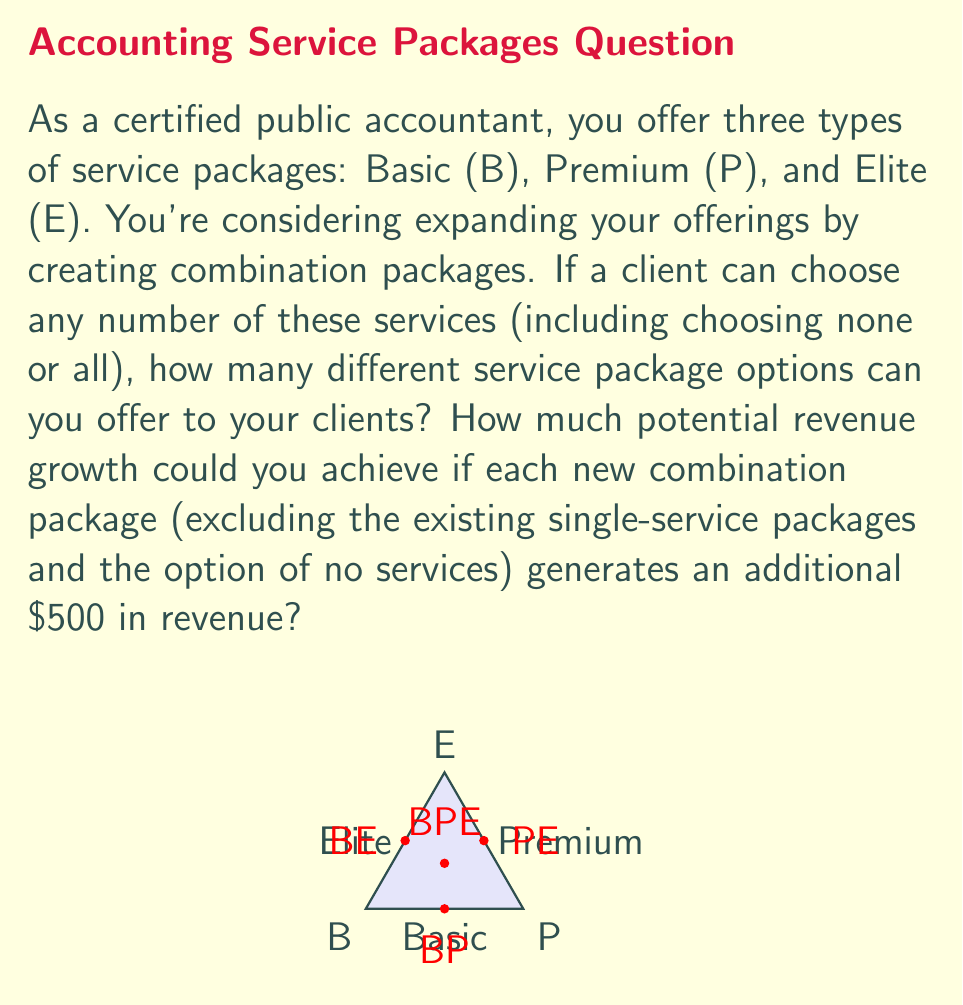Teach me how to tackle this problem. Let's approach this problem step-by-step using combinatorial analysis:

1) First, we need to calculate the total number of possible service package combinations. This is a perfect scenario for using the power set concept.

2) With 3 basic services (B, P, E), each package can be represented as a subset of these services. The number of subsets is given by $2^n$, where n is the number of elements in the set.

3) Therefore, the total number of possible packages is:

   $$ \text{Total Packages} = 2^3 = 8 $$

4) These 8 packages include:
   - No services: {}
   - Single services: {B}, {P}, {E}
   - Double services: {B,P}, {B,E}, {P,E}
   - All services: {B,P,E}

5) To calculate the new combination packages, we subtract the existing single-service packages and the no-service option:

   $$ \text{New Combinations} = 8 - 3 - 1 = 4 $$

6) These 4 new combinations are: {B,P}, {B,E}, {P,E}, and {B,P,E}

7) If each new combination generates an additional $500 in revenue, the potential revenue growth is:

   $$ \text{Revenue Growth} = 4 \times \$500 = \$2000 $$

Thus, by offering these combination packages, you could potentially increase your revenue by $2000.
Answer: 8 package options; $2000 potential revenue growth 